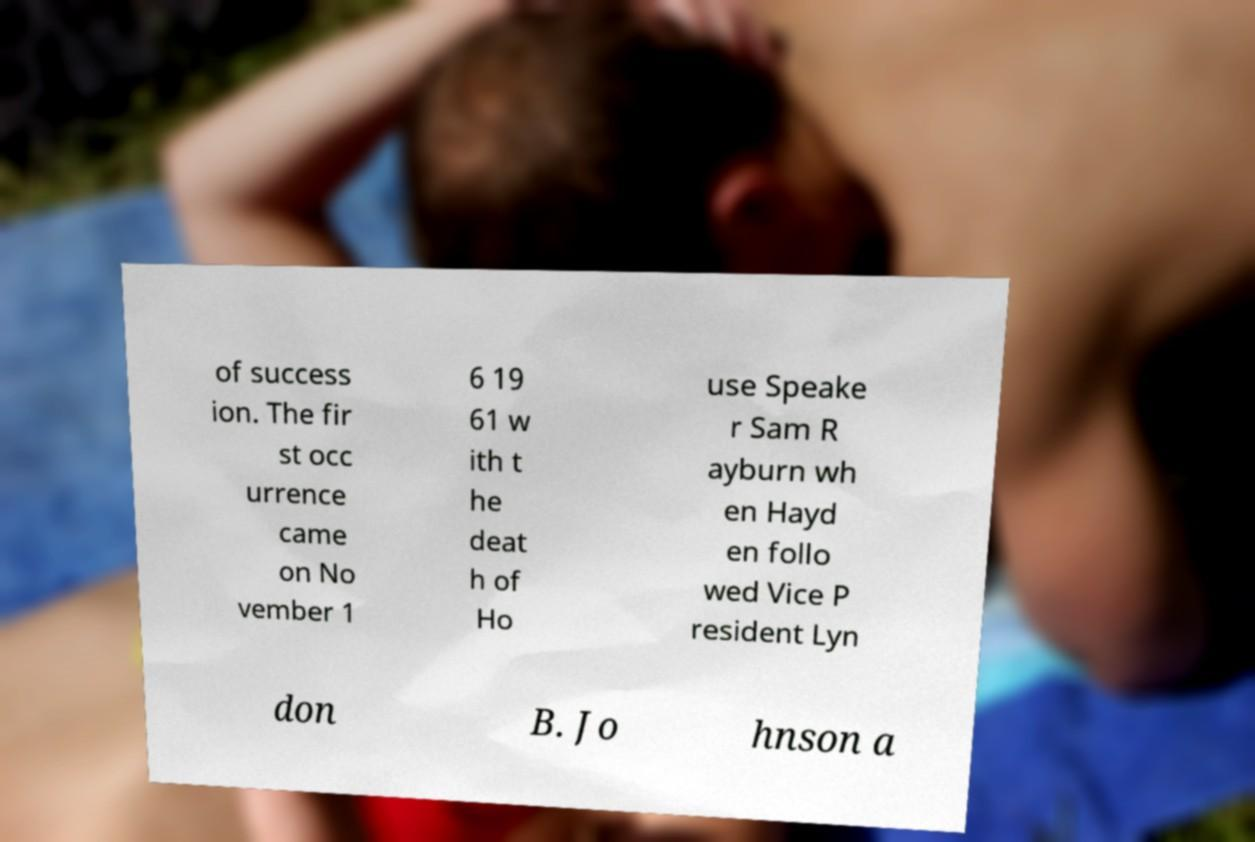Please read and relay the text visible in this image. What does it say? of success ion. The fir st occ urrence came on No vember 1 6 19 61 w ith t he deat h of Ho use Speake r Sam R ayburn wh en Hayd en follo wed Vice P resident Lyn don B. Jo hnson a 